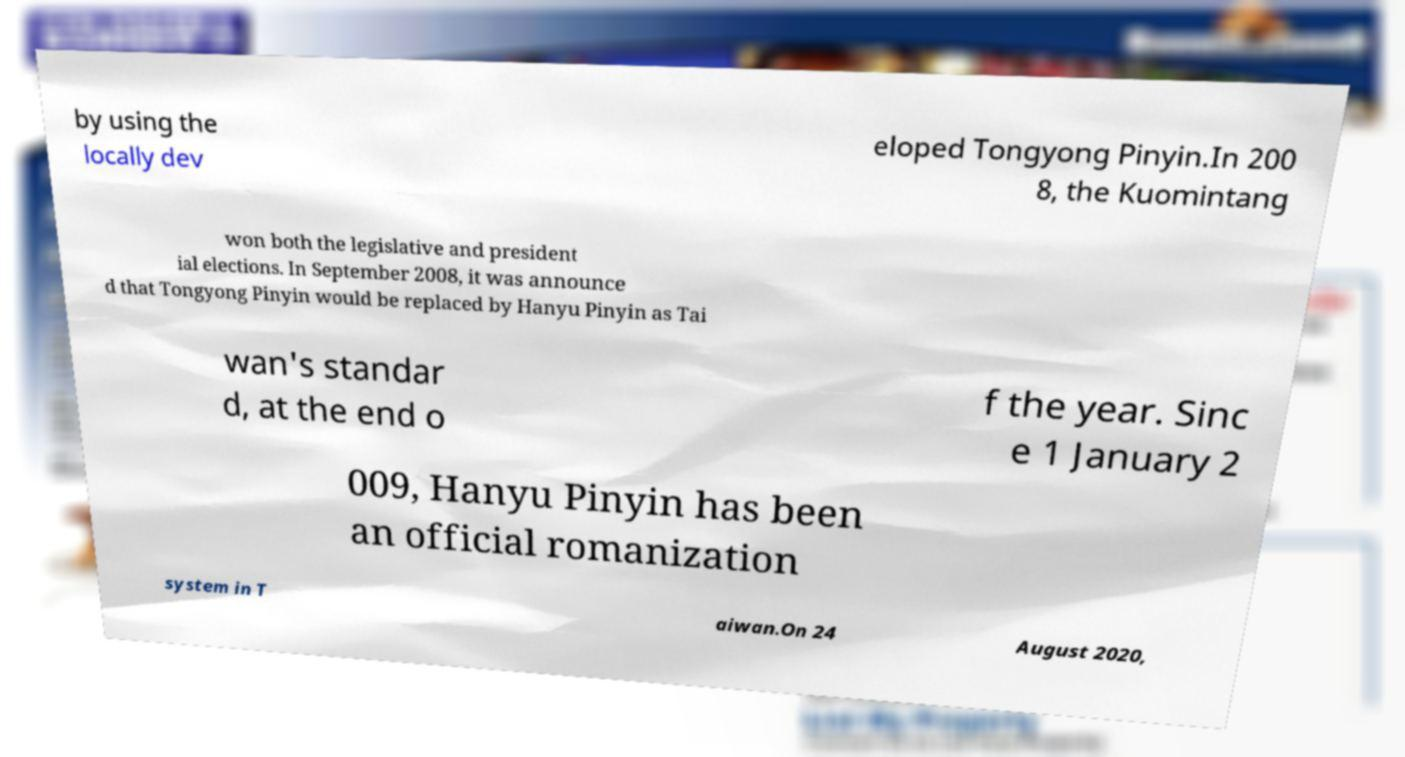Can you read and provide the text displayed in the image?This photo seems to have some interesting text. Can you extract and type it out for me? by using the locally dev eloped Tongyong Pinyin.In 200 8, the Kuomintang won both the legislative and president ial elections. In September 2008, it was announce d that Tongyong Pinyin would be replaced by Hanyu Pinyin as Tai wan's standar d, at the end o f the year. Sinc e 1 January 2 009, Hanyu Pinyin has been an official romanization system in T aiwan.On 24 August 2020, 